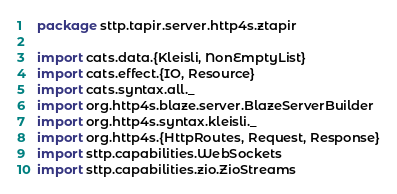Convert code to text. <code><loc_0><loc_0><loc_500><loc_500><_Scala_>package sttp.tapir.server.http4s.ztapir

import cats.data.{Kleisli, NonEmptyList}
import cats.effect.{IO, Resource}
import cats.syntax.all._
import org.http4s.blaze.server.BlazeServerBuilder
import org.http4s.syntax.kleisli._
import org.http4s.{HttpRoutes, Request, Response}
import sttp.capabilities.WebSockets
import sttp.capabilities.zio.ZioStreams</code> 